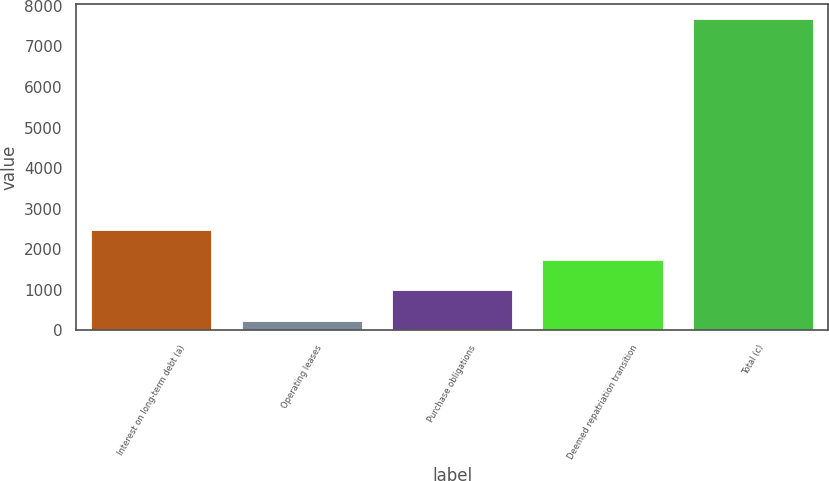Convert chart to OTSL. <chart><loc_0><loc_0><loc_500><loc_500><bar_chart><fcel>Interest on long-term debt (a)<fcel>Operating leases<fcel>Purchase obligations<fcel>Deemed repatriation transition<fcel>Total (c)<nl><fcel>2469.2<fcel>242<fcel>984.4<fcel>1726.8<fcel>7666<nl></chart> 